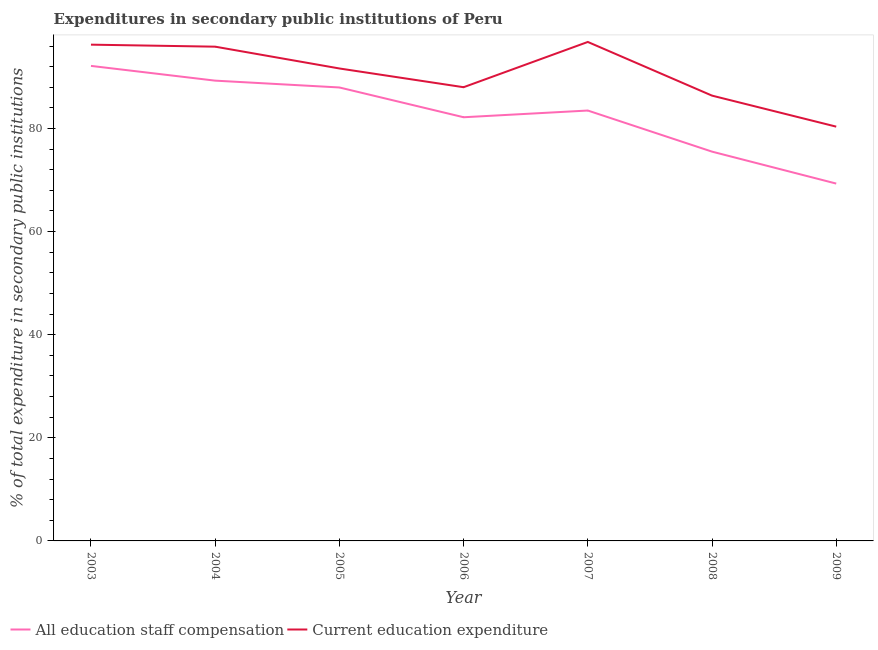How many different coloured lines are there?
Give a very brief answer. 2. Does the line corresponding to expenditure in staff compensation intersect with the line corresponding to expenditure in education?
Keep it short and to the point. No. Is the number of lines equal to the number of legend labels?
Provide a short and direct response. Yes. What is the expenditure in education in 2006?
Keep it short and to the point. 88.01. Across all years, what is the maximum expenditure in staff compensation?
Your answer should be compact. 92.15. Across all years, what is the minimum expenditure in staff compensation?
Give a very brief answer. 69.32. What is the total expenditure in education in the graph?
Ensure brevity in your answer.  635.33. What is the difference between the expenditure in staff compensation in 2003 and that in 2005?
Offer a very short reply. 4.18. What is the difference between the expenditure in education in 2008 and the expenditure in staff compensation in 2005?
Keep it short and to the point. -1.58. What is the average expenditure in education per year?
Your answer should be compact. 90.76. In the year 2005, what is the difference between the expenditure in education and expenditure in staff compensation?
Provide a succinct answer. 3.68. In how many years, is the expenditure in staff compensation greater than 16 %?
Your answer should be compact. 7. What is the ratio of the expenditure in education in 2007 to that in 2009?
Give a very brief answer. 1.2. Is the expenditure in staff compensation in 2003 less than that in 2008?
Ensure brevity in your answer.  No. What is the difference between the highest and the second highest expenditure in staff compensation?
Give a very brief answer. 2.86. What is the difference between the highest and the lowest expenditure in education?
Your answer should be compact. 16.43. Does the expenditure in staff compensation monotonically increase over the years?
Provide a short and direct response. No. Is the expenditure in education strictly greater than the expenditure in staff compensation over the years?
Provide a short and direct response. Yes. Is the expenditure in staff compensation strictly less than the expenditure in education over the years?
Ensure brevity in your answer.  Yes. How many lines are there?
Make the answer very short. 2. Does the graph contain any zero values?
Your response must be concise. No. Does the graph contain grids?
Give a very brief answer. No. Where does the legend appear in the graph?
Offer a terse response. Bottom left. How many legend labels are there?
Keep it short and to the point. 2. What is the title of the graph?
Ensure brevity in your answer.  Expenditures in secondary public institutions of Peru. Does "Lowest 10% of population" appear as one of the legend labels in the graph?
Keep it short and to the point. No. What is the label or title of the Y-axis?
Provide a succinct answer. % of total expenditure in secondary public institutions. What is the % of total expenditure in secondary public institutions in All education staff compensation in 2003?
Your answer should be very brief. 92.15. What is the % of total expenditure in secondary public institutions in Current education expenditure in 2003?
Make the answer very short. 96.27. What is the % of total expenditure in secondary public institutions of All education staff compensation in 2004?
Keep it short and to the point. 89.28. What is the % of total expenditure in secondary public institutions in Current education expenditure in 2004?
Your answer should be compact. 95.88. What is the % of total expenditure in secondary public institutions in All education staff compensation in 2005?
Provide a short and direct response. 87.96. What is the % of total expenditure in secondary public institutions in Current education expenditure in 2005?
Your response must be concise. 91.65. What is the % of total expenditure in secondary public institutions of All education staff compensation in 2006?
Provide a short and direct response. 82.18. What is the % of total expenditure in secondary public institutions of Current education expenditure in 2006?
Provide a short and direct response. 88.01. What is the % of total expenditure in secondary public institutions of All education staff compensation in 2007?
Offer a very short reply. 83.49. What is the % of total expenditure in secondary public institutions in Current education expenditure in 2007?
Your answer should be compact. 96.79. What is the % of total expenditure in secondary public institutions in All education staff compensation in 2008?
Your answer should be very brief. 75.51. What is the % of total expenditure in secondary public institutions in Current education expenditure in 2008?
Provide a short and direct response. 86.38. What is the % of total expenditure in secondary public institutions of All education staff compensation in 2009?
Provide a short and direct response. 69.32. What is the % of total expenditure in secondary public institutions of Current education expenditure in 2009?
Offer a very short reply. 80.36. Across all years, what is the maximum % of total expenditure in secondary public institutions of All education staff compensation?
Your response must be concise. 92.15. Across all years, what is the maximum % of total expenditure in secondary public institutions in Current education expenditure?
Your answer should be very brief. 96.79. Across all years, what is the minimum % of total expenditure in secondary public institutions of All education staff compensation?
Offer a terse response. 69.32. Across all years, what is the minimum % of total expenditure in secondary public institutions in Current education expenditure?
Offer a terse response. 80.36. What is the total % of total expenditure in secondary public institutions of All education staff compensation in the graph?
Make the answer very short. 579.89. What is the total % of total expenditure in secondary public institutions of Current education expenditure in the graph?
Provide a succinct answer. 635.33. What is the difference between the % of total expenditure in secondary public institutions in All education staff compensation in 2003 and that in 2004?
Make the answer very short. 2.86. What is the difference between the % of total expenditure in secondary public institutions in Current education expenditure in 2003 and that in 2004?
Offer a terse response. 0.39. What is the difference between the % of total expenditure in secondary public institutions in All education staff compensation in 2003 and that in 2005?
Ensure brevity in your answer.  4.18. What is the difference between the % of total expenditure in secondary public institutions in Current education expenditure in 2003 and that in 2005?
Your response must be concise. 4.62. What is the difference between the % of total expenditure in secondary public institutions of All education staff compensation in 2003 and that in 2006?
Offer a very short reply. 9.96. What is the difference between the % of total expenditure in secondary public institutions of Current education expenditure in 2003 and that in 2006?
Offer a terse response. 8.25. What is the difference between the % of total expenditure in secondary public institutions of All education staff compensation in 2003 and that in 2007?
Offer a terse response. 8.66. What is the difference between the % of total expenditure in secondary public institutions in Current education expenditure in 2003 and that in 2007?
Ensure brevity in your answer.  -0.52. What is the difference between the % of total expenditure in secondary public institutions in All education staff compensation in 2003 and that in 2008?
Make the answer very short. 16.63. What is the difference between the % of total expenditure in secondary public institutions in Current education expenditure in 2003 and that in 2008?
Keep it short and to the point. 9.89. What is the difference between the % of total expenditure in secondary public institutions of All education staff compensation in 2003 and that in 2009?
Offer a very short reply. 22.83. What is the difference between the % of total expenditure in secondary public institutions of Current education expenditure in 2003 and that in 2009?
Offer a terse response. 15.9. What is the difference between the % of total expenditure in secondary public institutions in All education staff compensation in 2004 and that in 2005?
Offer a very short reply. 1.32. What is the difference between the % of total expenditure in secondary public institutions of Current education expenditure in 2004 and that in 2005?
Your answer should be compact. 4.23. What is the difference between the % of total expenditure in secondary public institutions of All education staff compensation in 2004 and that in 2006?
Offer a very short reply. 7.1. What is the difference between the % of total expenditure in secondary public institutions of Current education expenditure in 2004 and that in 2006?
Ensure brevity in your answer.  7.86. What is the difference between the % of total expenditure in secondary public institutions in All education staff compensation in 2004 and that in 2007?
Ensure brevity in your answer.  5.8. What is the difference between the % of total expenditure in secondary public institutions of Current education expenditure in 2004 and that in 2007?
Your answer should be compact. -0.91. What is the difference between the % of total expenditure in secondary public institutions of All education staff compensation in 2004 and that in 2008?
Offer a very short reply. 13.77. What is the difference between the % of total expenditure in secondary public institutions in Current education expenditure in 2004 and that in 2008?
Provide a short and direct response. 9.5. What is the difference between the % of total expenditure in secondary public institutions of All education staff compensation in 2004 and that in 2009?
Make the answer very short. 19.97. What is the difference between the % of total expenditure in secondary public institutions of Current education expenditure in 2004 and that in 2009?
Your answer should be very brief. 15.51. What is the difference between the % of total expenditure in secondary public institutions of All education staff compensation in 2005 and that in 2006?
Provide a succinct answer. 5.78. What is the difference between the % of total expenditure in secondary public institutions of Current education expenditure in 2005 and that in 2006?
Ensure brevity in your answer.  3.63. What is the difference between the % of total expenditure in secondary public institutions of All education staff compensation in 2005 and that in 2007?
Ensure brevity in your answer.  4.47. What is the difference between the % of total expenditure in secondary public institutions in Current education expenditure in 2005 and that in 2007?
Offer a very short reply. -5.14. What is the difference between the % of total expenditure in secondary public institutions in All education staff compensation in 2005 and that in 2008?
Provide a short and direct response. 12.45. What is the difference between the % of total expenditure in secondary public institutions in Current education expenditure in 2005 and that in 2008?
Provide a succinct answer. 5.27. What is the difference between the % of total expenditure in secondary public institutions of All education staff compensation in 2005 and that in 2009?
Your answer should be compact. 18.64. What is the difference between the % of total expenditure in secondary public institutions in Current education expenditure in 2005 and that in 2009?
Keep it short and to the point. 11.28. What is the difference between the % of total expenditure in secondary public institutions in All education staff compensation in 2006 and that in 2007?
Your answer should be compact. -1.3. What is the difference between the % of total expenditure in secondary public institutions in Current education expenditure in 2006 and that in 2007?
Provide a short and direct response. -8.78. What is the difference between the % of total expenditure in secondary public institutions in All education staff compensation in 2006 and that in 2008?
Your response must be concise. 6.67. What is the difference between the % of total expenditure in secondary public institutions of Current education expenditure in 2006 and that in 2008?
Make the answer very short. 1.63. What is the difference between the % of total expenditure in secondary public institutions in All education staff compensation in 2006 and that in 2009?
Make the answer very short. 12.87. What is the difference between the % of total expenditure in secondary public institutions in Current education expenditure in 2006 and that in 2009?
Provide a succinct answer. 7.65. What is the difference between the % of total expenditure in secondary public institutions of All education staff compensation in 2007 and that in 2008?
Give a very brief answer. 7.97. What is the difference between the % of total expenditure in secondary public institutions in Current education expenditure in 2007 and that in 2008?
Provide a succinct answer. 10.41. What is the difference between the % of total expenditure in secondary public institutions in All education staff compensation in 2007 and that in 2009?
Your response must be concise. 14.17. What is the difference between the % of total expenditure in secondary public institutions of Current education expenditure in 2007 and that in 2009?
Offer a terse response. 16.43. What is the difference between the % of total expenditure in secondary public institutions of All education staff compensation in 2008 and that in 2009?
Make the answer very short. 6.2. What is the difference between the % of total expenditure in secondary public institutions of Current education expenditure in 2008 and that in 2009?
Offer a very short reply. 6.02. What is the difference between the % of total expenditure in secondary public institutions in All education staff compensation in 2003 and the % of total expenditure in secondary public institutions in Current education expenditure in 2004?
Your answer should be very brief. -3.73. What is the difference between the % of total expenditure in secondary public institutions of All education staff compensation in 2003 and the % of total expenditure in secondary public institutions of Current education expenditure in 2005?
Make the answer very short. 0.5. What is the difference between the % of total expenditure in secondary public institutions of All education staff compensation in 2003 and the % of total expenditure in secondary public institutions of Current education expenditure in 2006?
Keep it short and to the point. 4.13. What is the difference between the % of total expenditure in secondary public institutions in All education staff compensation in 2003 and the % of total expenditure in secondary public institutions in Current education expenditure in 2007?
Ensure brevity in your answer.  -4.64. What is the difference between the % of total expenditure in secondary public institutions of All education staff compensation in 2003 and the % of total expenditure in secondary public institutions of Current education expenditure in 2008?
Provide a short and direct response. 5.77. What is the difference between the % of total expenditure in secondary public institutions in All education staff compensation in 2003 and the % of total expenditure in secondary public institutions in Current education expenditure in 2009?
Provide a short and direct response. 11.78. What is the difference between the % of total expenditure in secondary public institutions of All education staff compensation in 2004 and the % of total expenditure in secondary public institutions of Current education expenditure in 2005?
Provide a succinct answer. -2.36. What is the difference between the % of total expenditure in secondary public institutions in All education staff compensation in 2004 and the % of total expenditure in secondary public institutions in Current education expenditure in 2006?
Provide a short and direct response. 1.27. What is the difference between the % of total expenditure in secondary public institutions of All education staff compensation in 2004 and the % of total expenditure in secondary public institutions of Current education expenditure in 2007?
Your answer should be very brief. -7.5. What is the difference between the % of total expenditure in secondary public institutions in All education staff compensation in 2004 and the % of total expenditure in secondary public institutions in Current education expenditure in 2008?
Give a very brief answer. 2.91. What is the difference between the % of total expenditure in secondary public institutions of All education staff compensation in 2004 and the % of total expenditure in secondary public institutions of Current education expenditure in 2009?
Your answer should be very brief. 8.92. What is the difference between the % of total expenditure in secondary public institutions in All education staff compensation in 2005 and the % of total expenditure in secondary public institutions in Current education expenditure in 2006?
Your response must be concise. -0.05. What is the difference between the % of total expenditure in secondary public institutions in All education staff compensation in 2005 and the % of total expenditure in secondary public institutions in Current education expenditure in 2007?
Ensure brevity in your answer.  -8.83. What is the difference between the % of total expenditure in secondary public institutions in All education staff compensation in 2005 and the % of total expenditure in secondary public institutions in Current education expenditure in 2008?
Your answer should be very brief. 1.58. What is the difference between the % of total expenditure in secondary public institutions in All education staff compensation in 2005 and the % of total expenditure in secondary public institutions in Current education expenditure in 2009?
Offer a very short reply. 7.6. What is the difference between the % of total expenditure in secondary public institutions in All education staff compensation in 2006 and the % of total expenditure in secondary public institutions in Current education expenditure in 2007?
Make the answer very short. -14.6. What is the difference between the % of total expenditure in secondary public institutions of All education staff compensation in 2006 and the % of total expenditure in secondary public institutions of Current education expenditure in 2008?
Provide a succinct answer. -4.19. What is the difference between the % of total expenditure in secondary public institutions in All education staff compensation in 2006 and the % of total expenditure in secondary public institutions in Current education expenditure in 2009?
Keep it short and to the point. 1.82. What is the difference between the % of total expenditure in secondary public institutions in All education staff compensation in 2007 and the % of total expenditure in secondary public institutions in Current education expenditure in 2008?
Your answer should be very brief. -2.89. What is the difference between the % of total expenditure in secondary public institutions of All education staff compensation in 2007 and the % of total expenditure in secondary public institutions of Current education expenditure in 2009?
Ensure brevity in your answer.  3.13. What is the difference between the % of total expenditure in secondary public institutions in All education staff compensation in 2008 and the % of total expenditure in secondary public institutions in Current education expenditure in 2009?
Make the answer very short. -4.85. What is the average % of total expenditure in secondary public institutions in All education staff compensation per year?
Keep it short and to the point. 82.84. What is the average % of total expenditure in secondary public institutions in Current education expenditure per year?
Offer a very short reply. 90.76. In the year 2003, what is the difference between the % of total expenditure in secondary public institutions in All education staff compensation and % of total expenditure in secondary public institutions in Current education expenditure?
Offer a very short reply. -4.12. In the year 2004, what is the difference between the % of total expenditure in secondary public institutions of All education staff compensation and % of total expenditure in secondary public institutions of Current education expenditure?
Your answer should be compact. -6.59. In the year 2005, what is the difference between the % of total expenditure in secondary public institutions of All education staff compensation and % of total expenditure in secondary public institutions of Current education expenditure?
Give a very brief answer. -3.68. In the year 2006, what is the difference between the % of total expenditure in secondary public institutions in All education staff compensation and % of total expenditure in secondary public institutions in Current education expenditure?
Your answer should be compact. -5.83. In the year 2007, what is the difference between the % of total expenditure in secondary public institutions in All education staff compensation and % of total expenditure in secondary public institutions in Current education expenditure?
Provide a short and direct response. -13.3. In the year 2008, what is the difference between the % of total expenditure in secondary public institutions of All education staff compensation and % of total expenditure in secondary public institutions of Current education expenditure?
Provide a short and direct response. -10.86. In the year 2009, what is the difference between the % of total expenditure in secondary public institutions in All education staff compensation and % of total expenditure in secondary public institutions in Current education expenditure?
Give a very brief answer. -11.04. What is the ratio of the % of total expenditure in secondary public institutions in All education staff compensation in 2003 to that in 2004?
Provide a succinct answer. 1.03. What is the ratio of the % of total expenditure in secondary public institutions in Current education expenditure in 2003 to that in 2004?
Ensure brevity in your answer.  1. What is the ratio of the % of total expenditure in secondary public institutions in All education staff compensation in 2003 to that in 2005?
Your answer should be very brief. 1.05. What is the ratio of the % of total expenditure in secondary public institutions in Current education expenditure in 2003 to that in 2005?
Keep it short and to the point. 1.05. What is the ratio of the % of total expenditure in secondary public institutions of All education staff compensation in 2003 to that in 2006?
Give a very brief answer. 1.12. What is the ratio of the % of total expenditure in secondary public institutions of Current education expenditure in 2003 to that in 2006?
Your answer should be very brief. 1.09. What is the ratio of the % of total expenditure in secondary public institutions of All education staff compensation in 2003 to that in 2007?
Give a very brief answer. 1.1. What is the ratio of the % of total expenditure in secondary public institutions of All education staff compensation in 2003 to that in 2008?
Your response must be concise. 1.22. What is the ratio of the % of total expenditure in secondary public institutions of Current education expenditure in 2003 to that in 2008?
Give a very brief answer. 1.11. What is the ratio of the % of total expenditure in secondary public institutions of All education staff compensation in 2003 to that in 2009?
Offer a terse response. 1.33. What is the ratio of the % of total expenditure in secondary public institutions in Current education expenditure in 2003 to that in 2009?
Ensure brevity in your answer.  1.2. What is the ratio of the % of total expenditure in secondary public institutions of Current education expenditure in 2004 to that in 2005?
Your response must be concise. 1.05. What is the ratio of the % of total expenditure in secondary public institutions of All education staff compensation in 2004 to that in 2006?
Keep it short and to the point. 1.09. What is the ratio of the % of total expenditure in secondary public institutions of Current education expenditure in 2004 to that in 2006?
Offer a terse response. 1.09. What is the ratio of the % of total expenditure in secondary public institutions of All education staff compensation in 2004 to that in 2007?
Your answer should be very brief. 1.07. What is the ratio of the % of total expenditure in secondary public institutions of Current education expenditure in 2004 to that in 2007?
Offer a very short reply. 0.99. What is the ratio of the % of total expenditure in secondary public institutions of All education staff compensation in 2004 to that in 2008?
Your response must be concise. 1.18. What is the ratio of the % of total expenditure in secondary public institutions in Current education expenditure in 2004 to that in 2008?
Keep it short and to the point. 1.11. What is the ratio of the % of total expenditure in secondary public institutions of All education staff compensation in 2004 to that in 2009?
Your response must be concise. 1.29. What is the ratio of the % of total expenditure in secondary public institutions in Current education expenditure in 2004 to that in 2009?
Your answer should be very brief. 1.19. What is the ratio of the % of total expenditure in secondary public institutions of All education staff compensation in 2005 to that in 2006?
Your answer should be compact. 1.07. What is the ratio of the % of total expenditure in secondary public institutions in Current education expenditure in 2005 to that in 2006?
Keep it short and to the point. 1.04. What is the ratio of the % of total expenditure in secondary public institutions in All education staff compensation in 2005 to that in 2007?
Offer a terse response. 1.05. What is the ratio of the % of total expenditure in secondary public institutions of Current education expenditure in 2005 to that in 2007?
Your response must be concise. 0.95. What is the ratio of the % of total expenditure in secondary public institutions of All education staff compensation in 2005 to that in 2008?
Make the answer very short. 1.16. What is the ratio of the % of total expenditure in secondary public institutions of Current education expenditure in 2005 to that in 2008?
Keep it short and to the point. 1.06. What is the ratio of the % of total expenditure in secondary public institutions in All education staff compensation in 2005 to that in 2009?
Your answer should be very brief. 1.27. What is the ratio of the % of total expenditure in secondary public institutions in Current education expenditure in 2005 to that in 2009?
Your response must be concise. 1.14. What is the ratio of the % of total expenditure in secondary public institutions of All education staff compensation in 2006 to that in 2007?
Provide a succinct answer. 0.98. What is the ratio of the % of total expenditure in secondary public institutions in Current education expenditure in 2006 to that in 2007?
Your response must be concise. 0.91. What is the ratio of the % of total expenditure in secondary public institutions of All education staff compensation in 2006 to that in 2008?
Make the answer very short. 1.09. What is the ratio of the % of total expenditure in secondary public institutions in Current education expenditure in 2006 to that in 2008?
Your answer should be very brief. 1.02. What is the ratio of the % of total expenditure in secondary public institutions in All education staff compensation in 2006 to that in 2009?
Keep it short and to the point. 1.19. What is the ratio of the % of total expenditure in secondary public institutions of Current education expenditure in 2006 to that in 2009?
Your answer should be compact. 1.1. What is the ratio of the % of total expenditure in secondary public institutions in All education staff compensation in 2007 to that in 2008?
Ensure brevity in your answer.  1.11. What is the ratio of the % of total expenditure in secondary public institutions of Current education expenditure in 2007 to that in 2008?
Ensure brevity in your answer.  1.12. What is the ratio of the % of total expenditure in secondary public institutions in All education staff compensation in 2007 to that in 2009?
Offer a very short reply. 1.2. What is the ratio of the % of total expenditure in secondary public institutions of Current education expenditure in 2007 to that in 2009?
Make the answer very short. 1.2. What is the ratio of the % of total expenditure in secondary public institutions in All education staff compensation in 2008 to that in 2009?
Offer a terse response. 1.09. What is the ratio of the % of total expenditure in secondary public institutions of Current education expenditure in 2008 to that in 2009?
Your answer should be compact. 1.07. What is the difference between the highest and the second highest % of total expenditure in secondary public institutions of All education staff compensation?
Your answer should be compact. 2.86. What is the difference between the highest and the second highest % of total expenditure in secondary public institutions in Current education expenditure?
Provide a succinct answer. 0.52. What is the difference between the highest and the lowest % of total expenditure in secondary public institutions of All education staff compensation?
Your answer should be very brief. 22.83. What is the difference between the highest and the lowest % of total expenditure in secondary public institutions of Current education expenditure?
Offer a terse response. 16.43. 